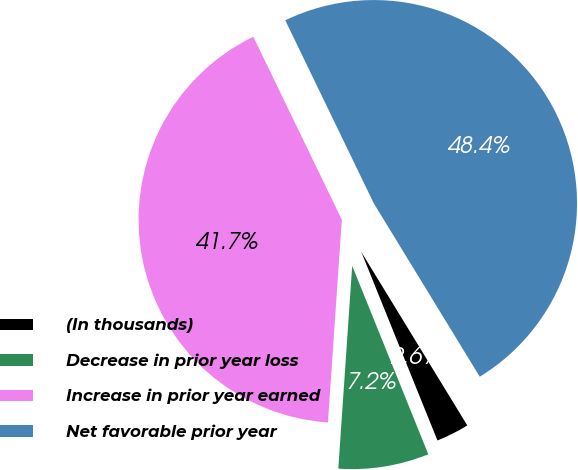Convert chart. <chart><loc_0><loc_0><loc_500><loc_500><pie_chart><fcel>(In thousands)<fcel>Decrease in prior year loss<fcel>Increase in prior year earned<fcel>Net favorable prior year<nl><fcel>2.62%<fcel>7.2%<fcel>41.74%<fcel>48.44%<nl></chart> 